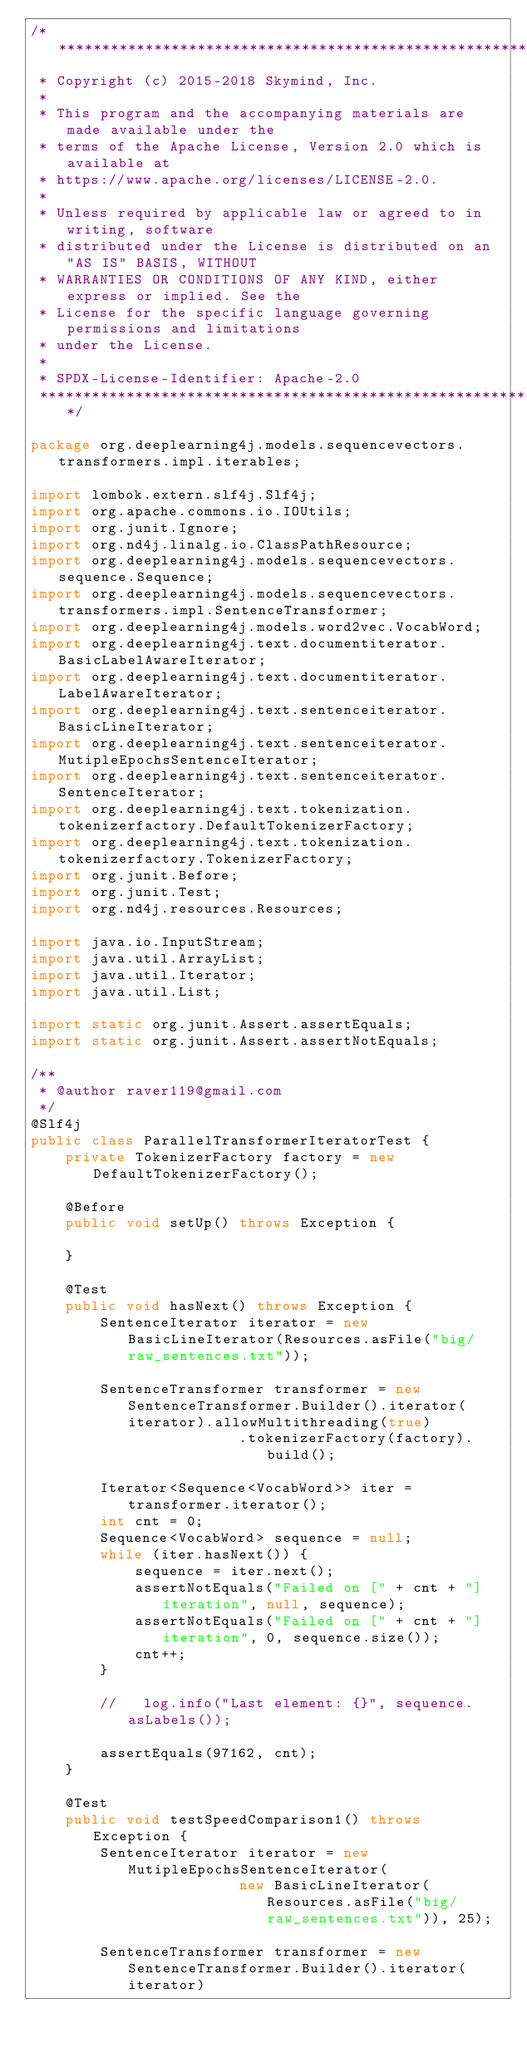<code> <loc_0><loc_0><loc_500><loc_500><_Java_>/*******************************************************************************
 * Copyright (c) 2015-2018 Skymind, Inc.
 *
 * This program and the accompanying materials are made available under the
 * terms of the Apache License, Version 2.0 which is available at
 * https://www.apache.org/licenses/LICENSE-2.0.
 *
 * Unless required by applicable law or agreed to in writing, software
 * distributed under the License is distributed on an "AS IS" BASIS, WITHOUT
 * WARRANTIES OR CONDITIONS OF ANY KIND, either express or implied. See the
 * License for the specific language governing permissions and limitations
 * under the License.
 *
 * SPDX-License-Identifier: Apache-2.0
 ******************************************************************************/

package org.deeplearning4j.models.sequencevectors.transformers.impl.iterables;

import lombok.extern.slf4j.Slf4j;
import org.apache.commons.io.IOUtils;
import org.junit.Ignore;
import org.nd4j.linalg.io.ClassPathResource;
import org.deeplearning4j.models.sequencevectors.sequence.Sequence;
import org.deeplearning4j.models.sequencevectors.transformers.impl.SentenceTransformer;
import org.deeplearning4j.models.word2vec.VocabWord;
import org.deeplearning4j.text.documentiterator.BasicLabelAwareIterator;
import org.deeplearning4j.text.documentiterator.LabelAwareIterator;
import org.deeplearning4j.text.sentenceiterator.BasicLineIterator;
import org.deeplearning4j.text.sentenceiterator.MutipleEpochsSentenceIterator;
import org.deeplearning4j.text.sentenceiterator.SentenceIterator;
import org.deeplearning4j.text.tokenization.tokenizerfactory.DefaultTokenizerFactory;
import org.deeplearning4j.text.tokenization.tokenizerfactory.TokenizerFactory;
import org.junit.Before;
import org.junit.Test;
import org.nd4j.resources.Resources;

import java.io.InputStream;
import java.util.ArrayList;
import java.util.Iterator;
import java.util.List;

import static org.junit.Assert.assertEquals;
import static org.junit.Assert.assertNotEquals;

/**
 * @author raver119@gmail.com
 */
@Slf4j
public class ParallelTransformerIteratorTest {
    private TokenizerFactory factory = new DefaultTokenizerFactory();

    @Before
    public void setUp() throws Exception {

    }

    @Test
    public void hasNext() throws Exception {
        SentenceIterator iterator = new BasicLineIterator(Resources.asFile("big/raw_sentences.txt"));

        SentenceTransformer transformer = new SentenceTransformer.Builder().iterator(iterator).allowMultithreading(true)
                        .tokenizerFactory(factory).build();

        Iterator<Sequence<VocabWord>> iter = transformer.iterator();
        int cnt = 0;
        Sequence<VocabWord> sequence = null;
        while (iter.hasNext()) {
            sequence = iter.next();
            assertNotEquals("Failed on [" + cnt + "] iteration", null, sequence);
            assertNotEquals("Failed on [" + cnt + "] iteration", 0, sequence.size());
            cnt++;
        }

        //   log.info("Last element: {}", sequence.asLabels());

        assertEquals(97162, cnt);
    }

    @Test
    public void testSpeedComparison1() throws Exception {
        SentenceIterator iterator = new MutipleEpochsSentenceIterator(
                        new BasicLineIterator(Resources.asFile("big/raw_sentences.txt")), 25);

        SentenceTransformer transformer = new SentenceTransformer.Builder().iterator(iterator)</code> 